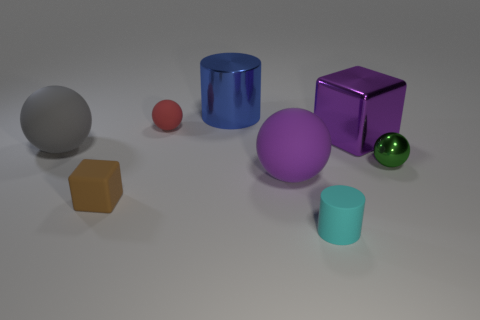Are there any rubber objects of the same size as the purple sphere?
Your answer should be compact. Yes. What is the material of the tiny ball behind the large object that is on the right side of the big purple matte thing?
Your answer should be very brief. Rubber. What number of cylinders are the same color as the matte cube?
Your response must be concise. 0. There is a gray thing that is the same material as the red sphere; what is its shape?
Your response must be concise. Sphere. What size is the rubber ball that is in front of the green shiny sphere?
Your answer should be very brief. Large. Are there an equal number of big gray matte balls that are behind the big blue metal thing and small spheres that are on the right side of the red sphere?
Keep it short and to the point. No. There is a small ball that is on the right side of the cylinder on the left side of the cylinder in front of the rubber cube; what color is it?
Provide a short and direct response. Green. What number of things are on the right side of the blue cylinder and in front of the small metallic sphere?
Offer a terse response. 2. Is the color of the matte ball that is in front of the large gray ball the same as the block that is to the right of the small brown block?
Ensure brevity in your answer.  Yes. What is the size of the green metal thing that is the same shape as the purple rubber thing?
Provide a succinct answer. Small. 